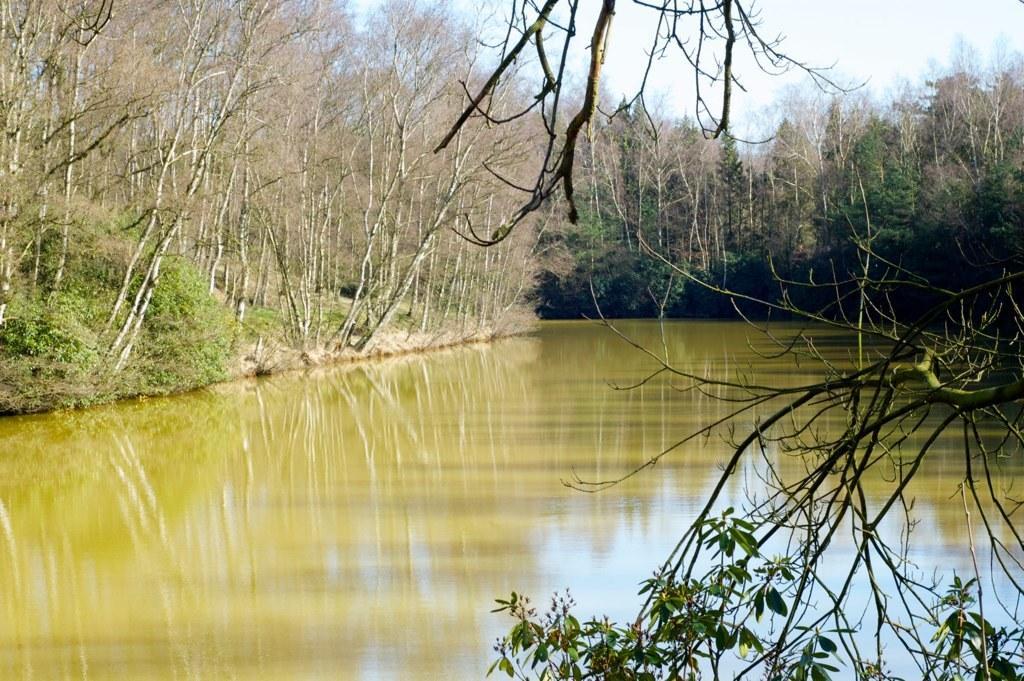Could you give a brief overview of what you see in this image? In the picture we can see the water, which is green in color and around it we can see plants and trees and in the background we can see a sky. 